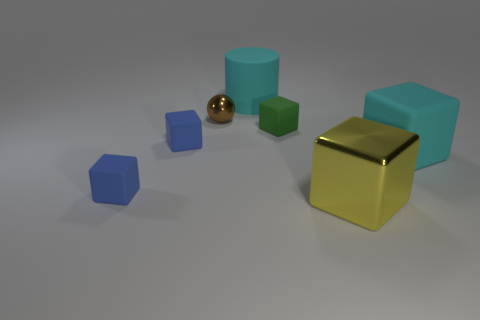Add 2 small green things. How many objects exist? 9 Add 1 rubber cubes. How many rubber cubes are left? 5 Add 7 large red objects. How many large red objects exist? 7 Subtract all yellow cubes. How many cubes are left? 4 Subtract all big yellow blocks. How many blocks are left? 4 Subtract 0 purple spheres. How many objects are left? 7 Subtract all cylinders. How many objects are left? 6 Subtract all cyan cubes. Subtract all green balls. How many cubes are left? 4 Subtract all red balls. How many red cylinders are left? 0 Subtract all large rubber cylinders. Subtract all big cyan balls. How many objects are left? 6 